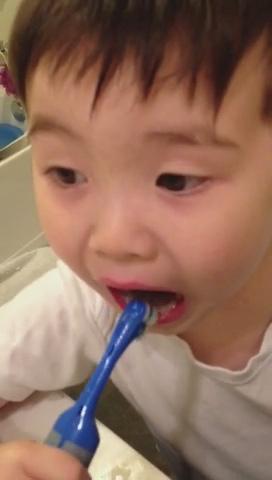How many people are in the picture?
Give a very brief answer. 1. 